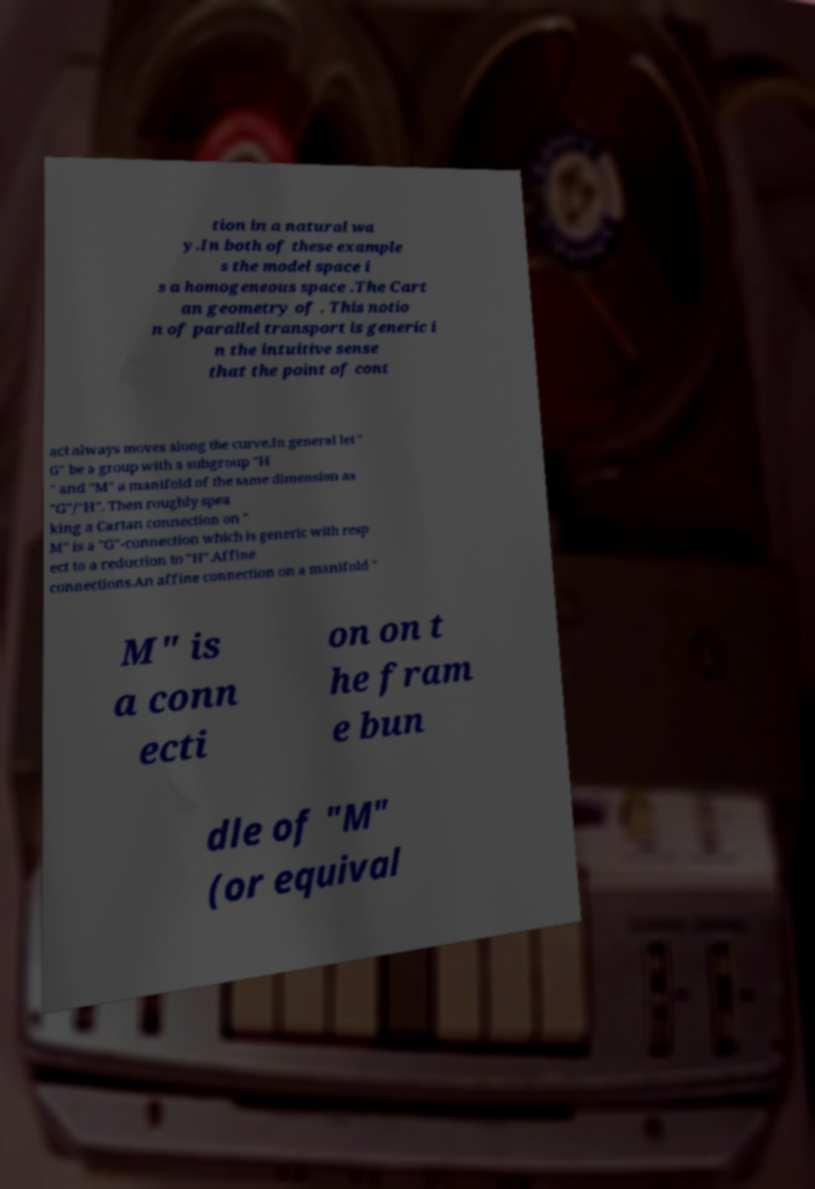Please identify and transcribe the text found in this image. tion in a natural wa y.In both of these example s the model space i s a homogeneous space .The Cart an geometry of . This notio n of parallel transport is generic i n the intuitive sense that the point of cont act always moves along the curve.In general let " G" be a group with a subgroup "H " and "M" a manifold of the same dimension as "G"/"H". Then roughly spea king a Cartan connection on " M" is a "G"-connection which is generic with resp ect to a reduction to "H".Affine connections.An affine connection on a manifold " M" is a conn ecti on on t he fram e bun dle of "M" (or equival 